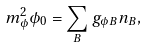<formula> <loc_0><loc_0><loc_500><loc_500>m _ { \phi } ^ { 2 } \phi _ { 0 } = \sum _ { B } g _ { \phi B } n _ { B } ,</formula> 